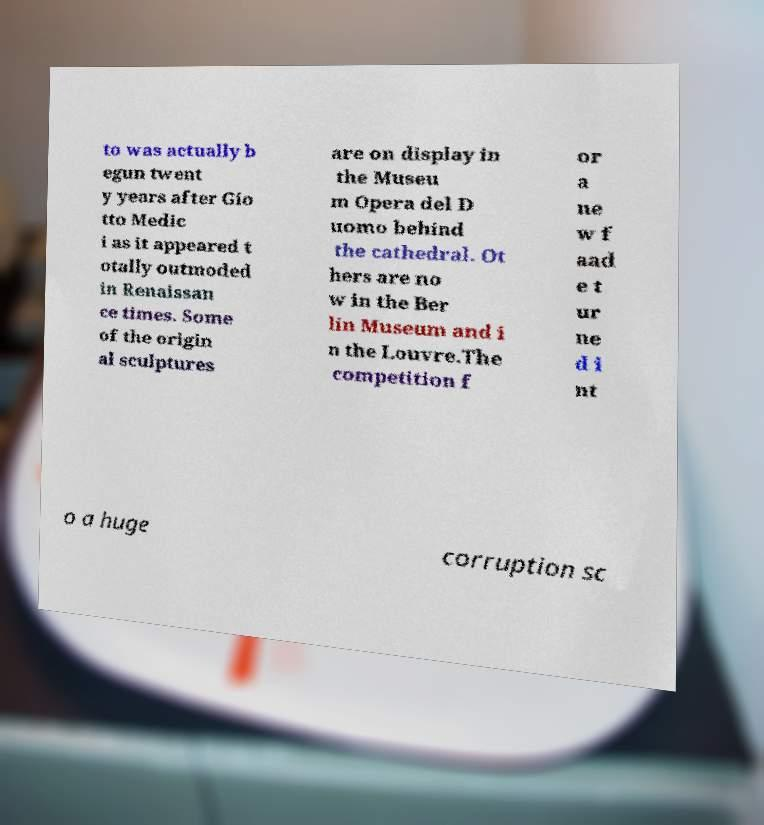I need the written content from this picture converted into text. Can you do that? to was actually b egun twent y years after Gio tto Medic i as it appeared t otally outmoded in Renaissan ce times. Some of the origin al sculptures are on display in the Museu m Opera del D uomo behind the cathedral. Ot hers are no w in the Ber lin Museum and i n the Louvre.The competition f or a ne w f aad e t ur ne d i nt o a huge corruption sc 